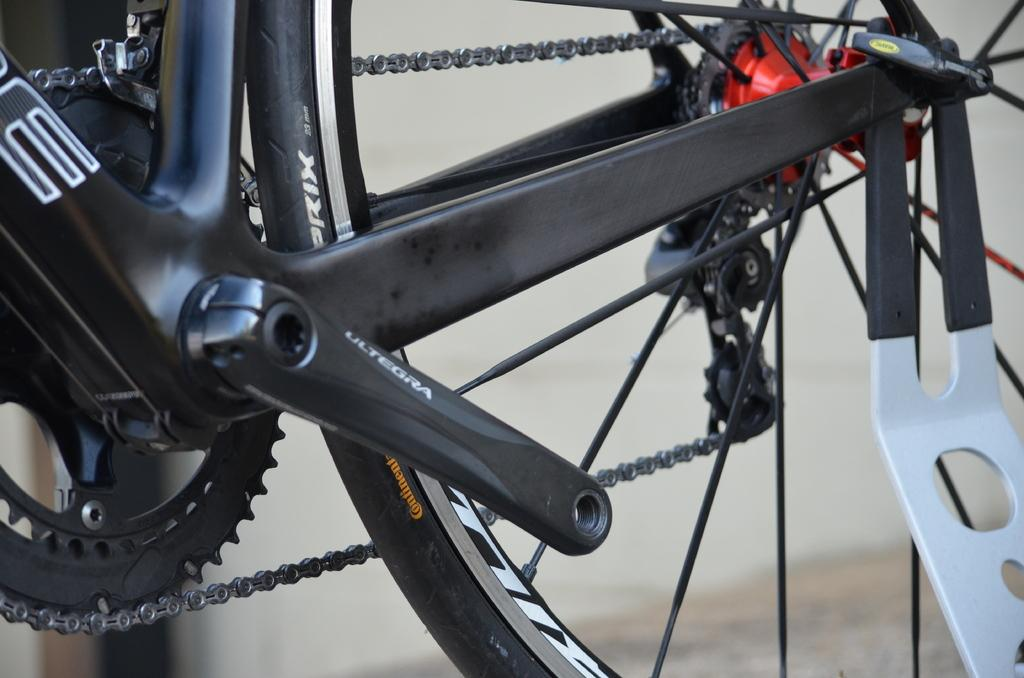What is the main subject in the center of the image? There is a bicycle in the center of the image. How does the tramp contribute to the value of the bicycle in the image? There is no tramp present in the image, and therefore no such interaction can be observed. 